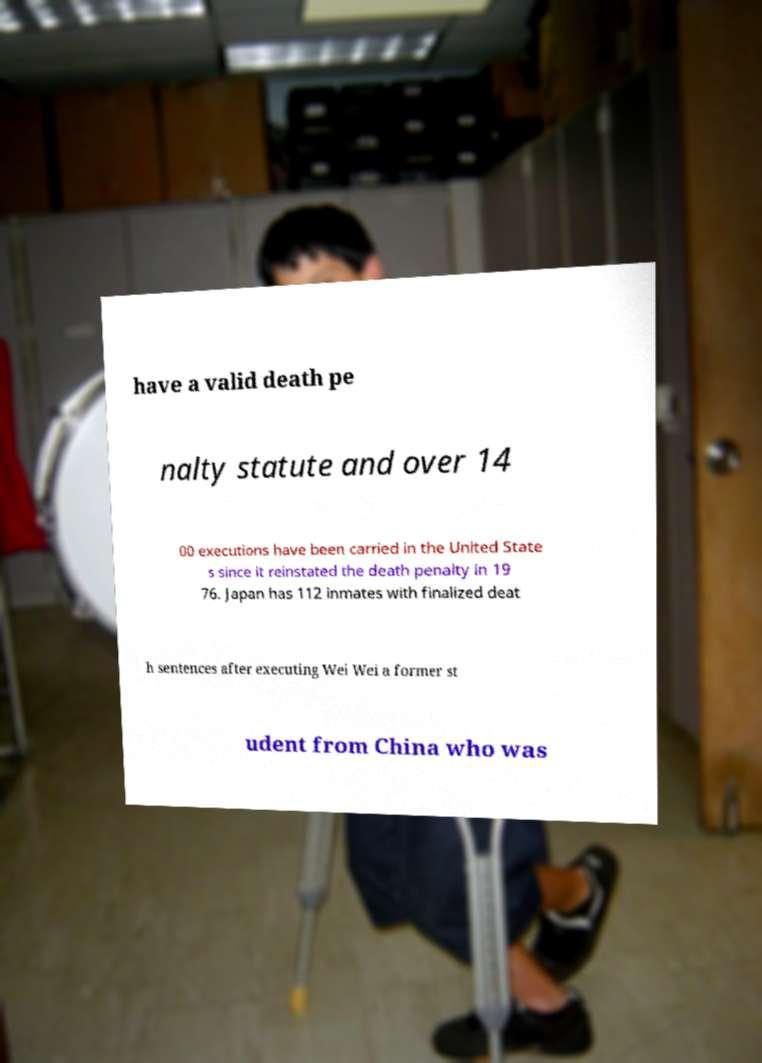Could you assist in decoding the text presented in this image and type it out clearly? have a valid death pe nalty statute and over 14 00 executions have been carried in the United State s since it reinstated the death penalty in 19 76. Japan has 112 inmates with finalized deat h sentences after executing Wei Wei a former st udent from China who was 